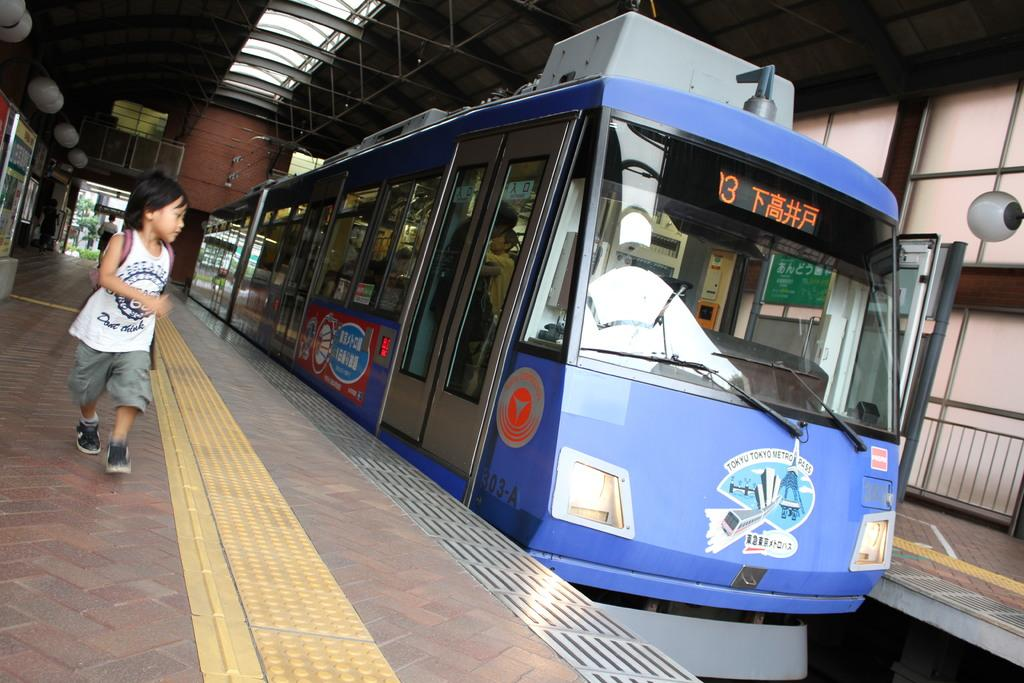What is the main subject of the image? The main subject of the image is a train. What else can be seen in the image besides the train? There is a platform, lights, boards, a roof, and a boy running on the platform on the left side of the image. Can you describe the platform in the image? The platform is a flat surface where people can wait for or get off the train. What is the purpose of the lights in the image? The lights are likely for illuminating the platform and train during nighttime or low-light conditions. Where is the drain located in the image? There is no drain present in the image. What type of rake is being used by the boy on the platform? The image does not show a boy using a rake; he is running on the platform. 